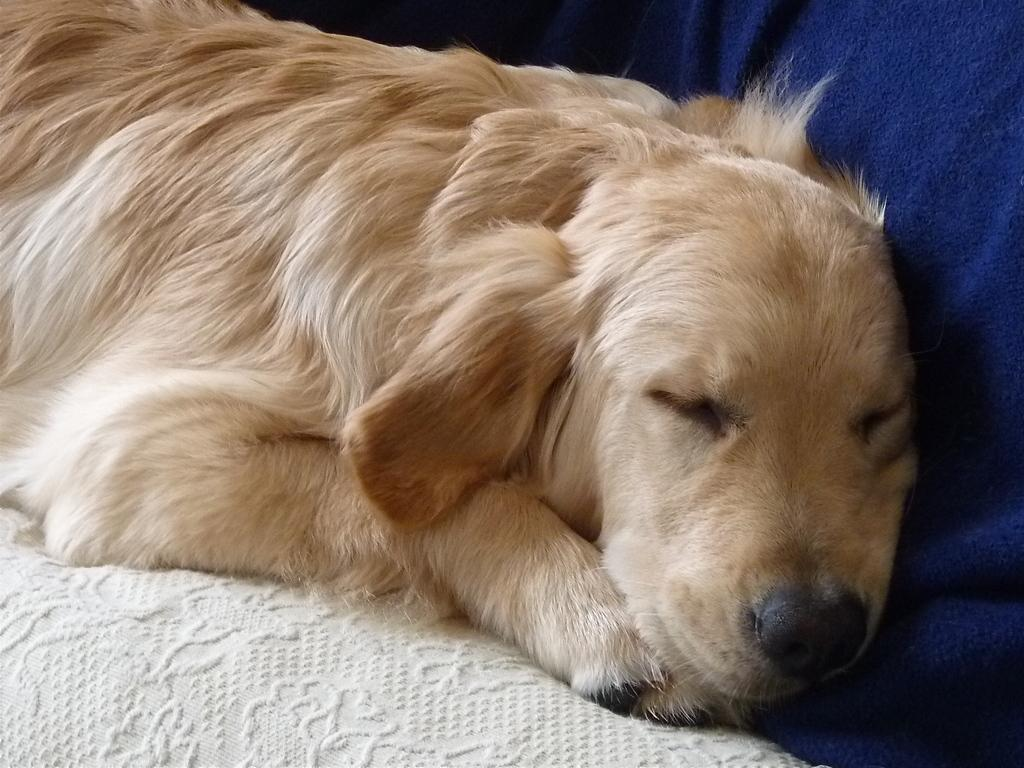What type of animal can be seen in the image? There is a dog in the image. What is the dog doing in the image? The dog is sleeping. What is located at the bottom of the image? There is a bed sheet at the bottom of the image. What can be seen on the right side of the image? There is a cloth on the right side of the image. What color is the curtain behind the dog in the image? There is no curtain present in the image; it only features a dog, a bed sheet, and a cloth. 